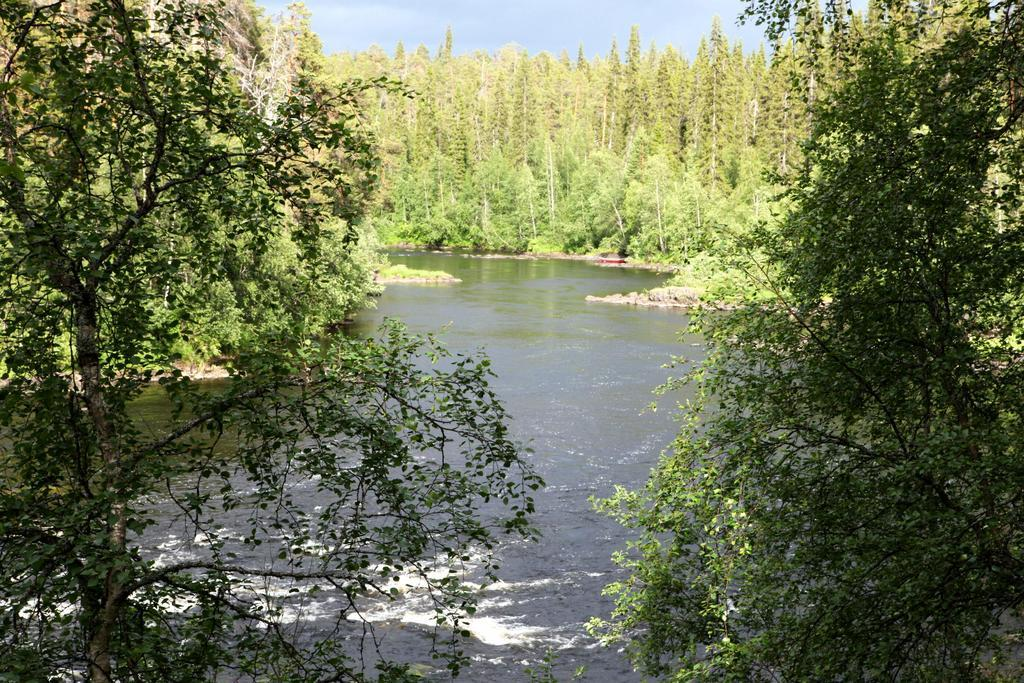What body of water is visible in the image? There is a lake in the image. What type of vegetation can be seen in the background of the image? There are trees in the background of the image. How many sails can be seen on the jellyfish in the image? There are no jellyfish or sails present in the image; it features a lake and trees. 